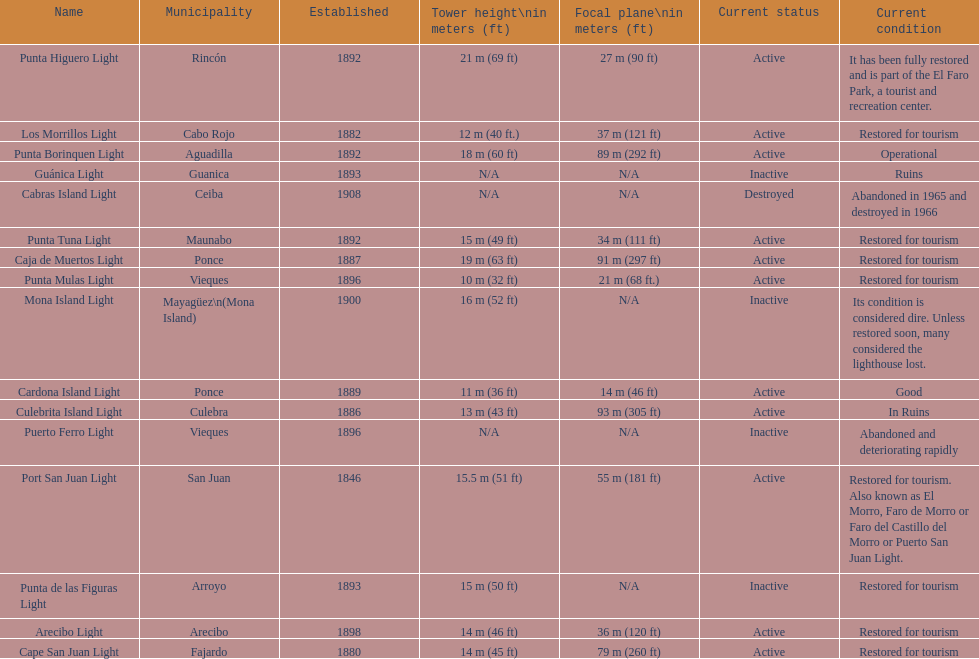What is the largest tower Punta Higuero Light. Write the full table. {'header': ['Name', 'Municipality', 'Established', 'Tower height\\nin meters (ft)', 'Focal plane\\nin meters (ft)', 'Current status', 'Current condition'], 'rows': [['Punta Higuero Light', 'Rincón', '1892', '21\xa0m (69\xa0ft)', '27\xa0m (90\xa0ft)', 'Active', 'It has been fully restored and is part of the El Faro Park, a tourist and recreation center.'], ['Los Morrillos Light', 'Cabo Rojo', '1882', '12\xa0m (40\xa0ft.)', '37\xa0m (121\xa0ft)', 'Active', 'Restored for tourism'], ['Punta Borinquen Light', 'Aguadilla', '1892', '18\xa0m (60\xa0ft)', '89\xa0m (292\xa0ft)', 'Active', 'Operational'], ['Guánica Light', 'Guanica', '1893', 'N/A', 'N/A', 'Inactive', 'Ruins'], ['Cabras Island Light', 'Ceiba', '1908', 'N/A', 'N/A', 'Destroyed', 'Abandoned in 1965 and destroyed in 1966'], ['Punta Tuna Light', 'Maunabo', '1892', '15\xa0m (49\xa0ft)', '34\xa0m (111\xa0ft)', 'Active', 'Restored for tourism'], ['Caja de Muertos Light', 'Ponce', '1887', '19\xa0m (63\xa0ft)', '91\xa0m (297\xa0ft)', 'Active', 'Restored for tourism'], ['Punta Mulas Light', 'Vieques', '1896', '10\xa0m (32\xa0ft)', '21\xa0m (68\xa0ft.)', 'Active', 'Restored for tourism'], ['Mona Island Light', 'Mayagüez\\n(Mona Island)', '1900', '16\xa0m (52\xa0ft)', 'N/A', 'Inactive', 'Its condition is considered dire. Unless restored soon, many considered the lighthouse lost.'], ['Cardona Island Light', 'Ponce', '1889', '11\xa0m (36\xa0ft)', '14\xa0m (46\xa0ft)', 'Active', 'Good'], ['Culebrita Island Light', 'Culebra', '1886', '13\xa0m (43\xa0ft)', '93\xa0m (305\xa0ft)', 'Active', 'In Ruins'], ['Puerto Ferro Light', 'Vieques', '1896', 'N/A', 'N/A', 'Inactive', 'Abandoned and deteriorating rapidly'], ['Port San Juan Light', 'San Juan', '1846', '15.5\xa0m (51\xa0ft)', '55\xa0m (181\xa0ft)', 'Active', 'Restored for tourism. Also known as El Morro, Faro de Morro or Faro del Castillo del Morro or Puerto San Juan Light.'], ['Punta de las Figuras Light', 'Arroyo', '1893', '15\xa0m (50\xa0ft)', 'N/A', 'Inactive', 'Restored for tourism'], ['Arecibo Light', 'Arecibo', '1898', '14\xa0m (46\xa0ft)', '36\xa0m (120\xa0ft)', 'Active', 'Restored for tourism'], ['Cape San Juan Light', 'Fajardo', '1880', '14\xa0m (45\xa0ft)', '79\xa0m (260\xa0ft)', 'Active', 'Restored for tourism']]} 